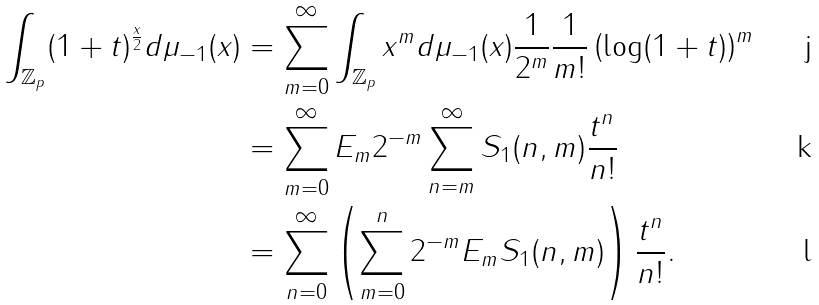Convert formula to latex. <formula><loc_0><loc_0><loc_500><loc_500>\int _ { \mathbb { Z } _ { p } } ( 1 + t ) ^ { \frac { x } { 2 } } d \mu _ { - 1 } ( x ) & = \sum _ { m = 0 } ^ { \infty } \int _ { \mathbb { Z } _ { p } } x ^ { m } d \mu _ { - 1 } ( x ) \frac { 1 } { 2 ^ { m } } \frac { 1 } { m ! } \left ( \log ( 1 + t ) \right ) ^ { m } \\ & = \sum _ { m = 0 } ^ { \infty } E _ { m } 2 ^ { - m } \sum _ { n = m } ^ { \infty } S _ { 1 } ( n , m ) \frac { t ^ { n } } { n ! } \\ & = \sum _ { n = 0 } ^ { \infty } \left ( \sum _ { m = 0 } ^ { n } 2 ^ { - m } E _ { m } S _ { 1 } ( n , m ) \right ) \frac { t ^ { n } } { n ! } .</formula> 